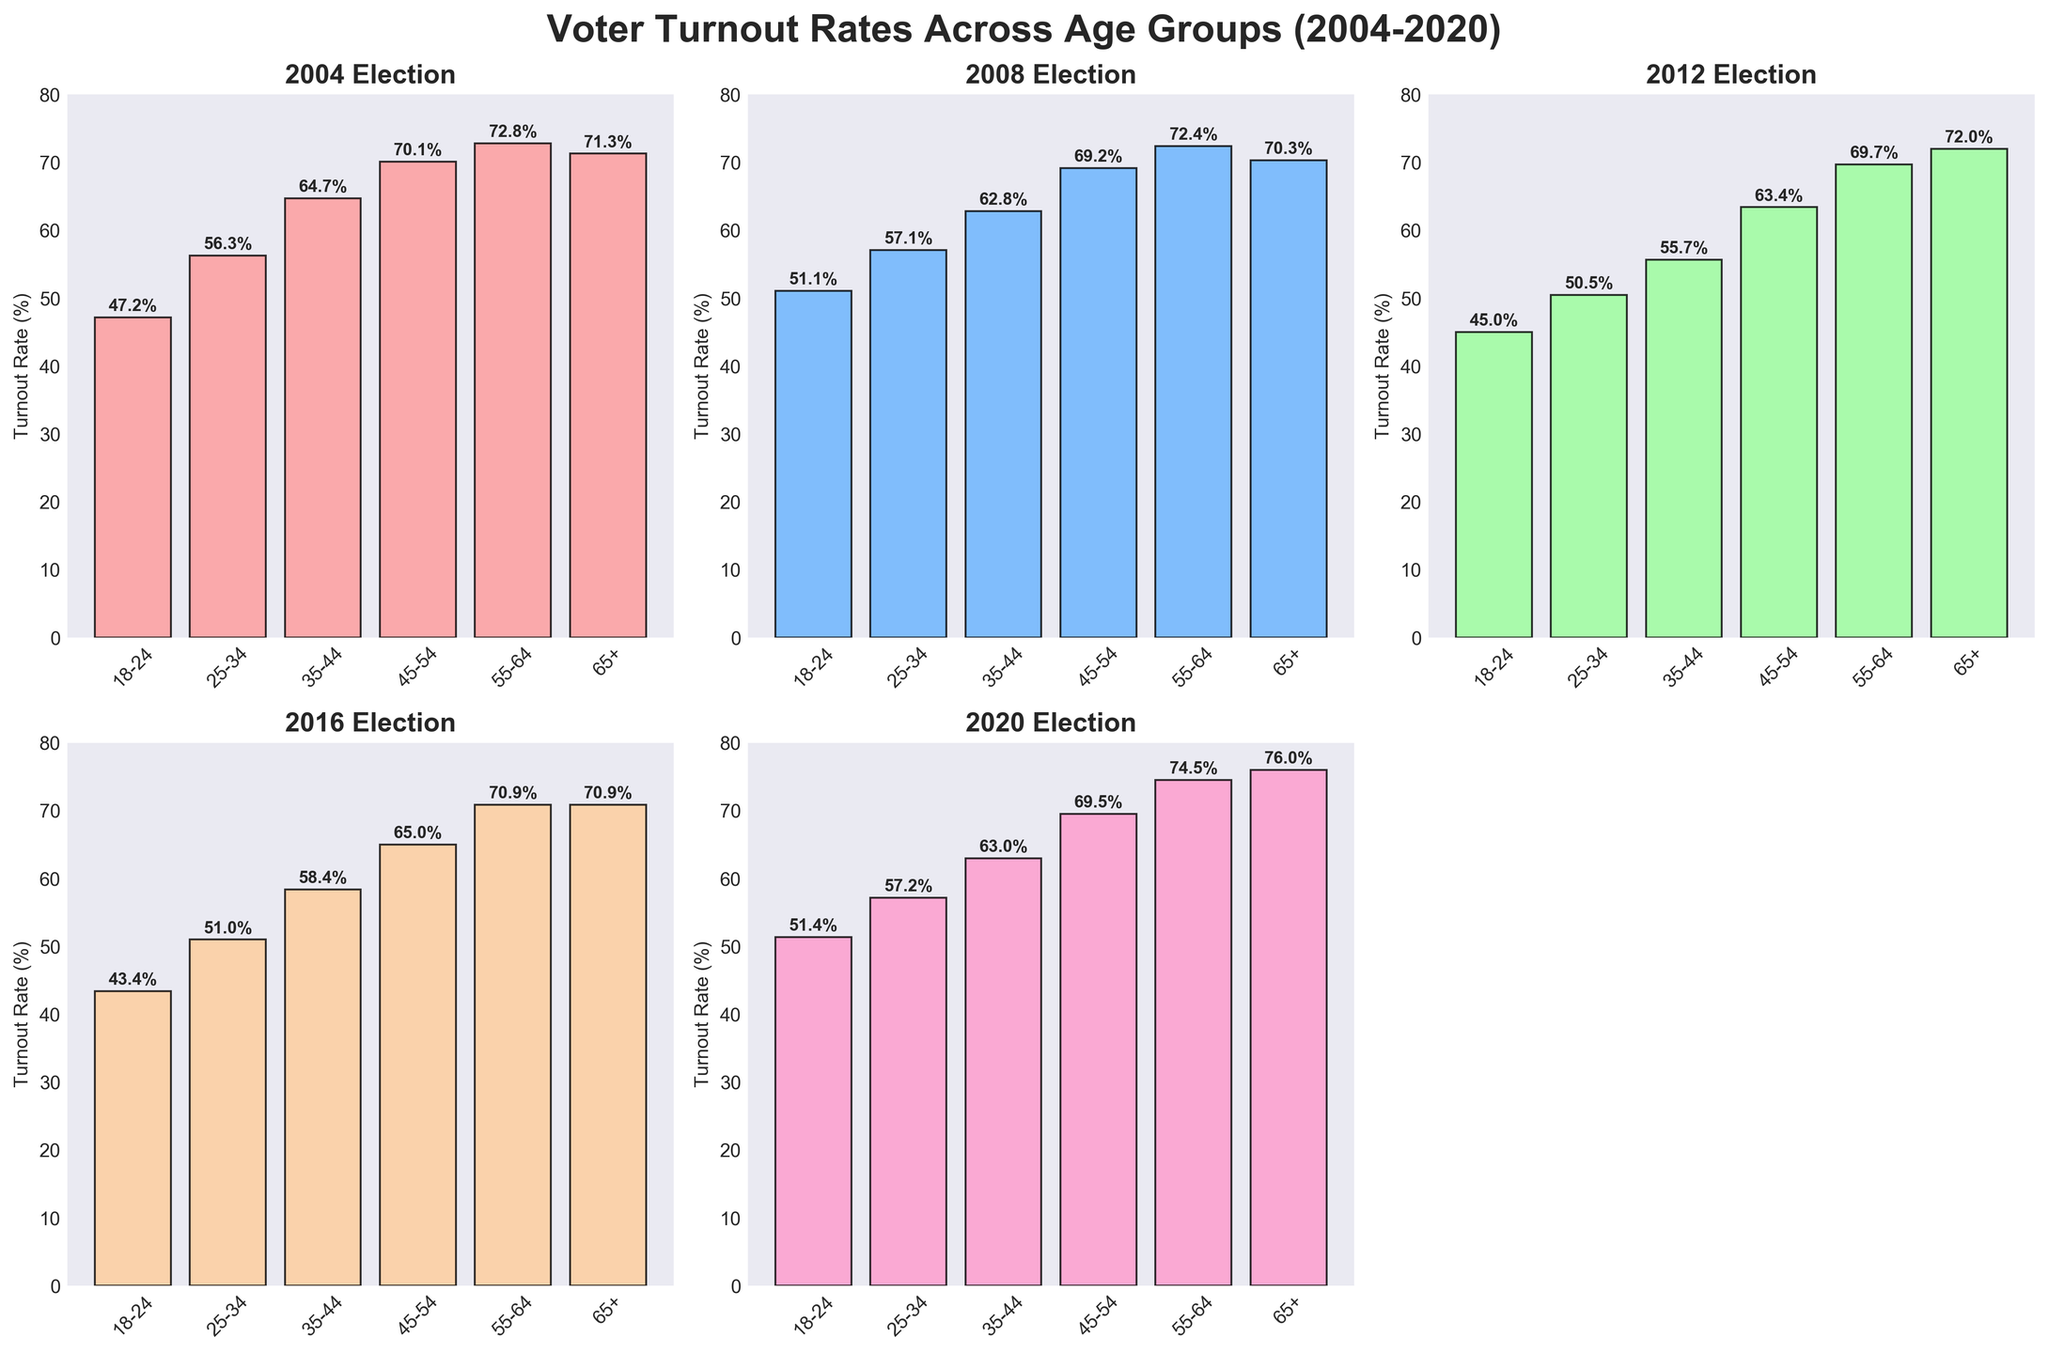What's the title of the figure? The title is usually displayed at the top of the figure in a larger and bold font. In this case, it reads "Voter Turnout Rates Across Age Groups (2004-2020)".
Answer: Voter Turnout Rates Across Age Groups (2004-2020) Which year had the highest voter turnout for the 25-34 age group? By examining each subplot, we can see that 2020 has the highest bar for the 25-34 age group, at 57.2%.
Answer: 2020 What is the voter turnout rate for the 18-24 age group in the 2008 election? Look at the bar for the 18-24 age group in the subplot for the 2008 election. The text on top of the bar indicates the value, which is 51.1%.
Answer: 51.1% How does the voter turnout rate for the 55-64 age group in 2012 compare to that in 2020? Compare the bars for the 55-64 age group in the 2012 and 2020 subplots. In 2012, the turnout rate is 69.7%, and in 2020, it’s 74.5%. 74.5% is greater than 69.7%.
Answer: 2020 is higher In which election year did the 35-44 age group see a lower voter turnout rate than in the previous election? Check the bars for the 35-44 age group in each election year. The voter turnout dropped from 2008 (62.8%) to 2012 (55.7%).
Answer: 2012 What is the average voter turnout rate across all age groups in the 2016 election? Sum up the voter turnout rates for all age groups in 2016 (43.4%, 51.0%, 58.4%, 65.0%, 70.9%, 70.9%) and divide by the number of age groups (6). (43.4 + 51.0 + 58.4 + 65.0 + 70.9 + 70.9) / 6 = 59.1%
Answer: 59.1% Which age group saw the most significant increase in voter turnout from 2016 to 2020? Compare the difference in turnout rates between 2016 and 2020 for each age group. The 65+ age group shows the largest increase, from 70.9% to 76.0%, a change of 5.1%.
Answer: 65+ Which age group consistently had the highest voter turnout rate across all election years? Look at each subplot and identify which age group has the tallest bar in a majority of the years. The 55-64 age group consistently has one of the highest turnout rates in all election years.
Answer: 55-64 How did the voter turnout rate for the 18-24 age group trend over the five elections? Track the bars for the 18-24 age group across the subplots: 47.2% in 2004, 51.1% in 2008, 45.0% in 2012, 43.4% in 2016, and 51.4% in 2020. The pattern is a slight increase, a dip, and then another increase.
Answer: Variable, with an overall increase from 2004 to 2020 What is the voter turnout rate for the 65+ age group in the 2004 election? Locate the bar corresponding to the 65+ age group in the 2004 subplot. The turnout rate shown is 71.3%.
Answer: 71.3% 